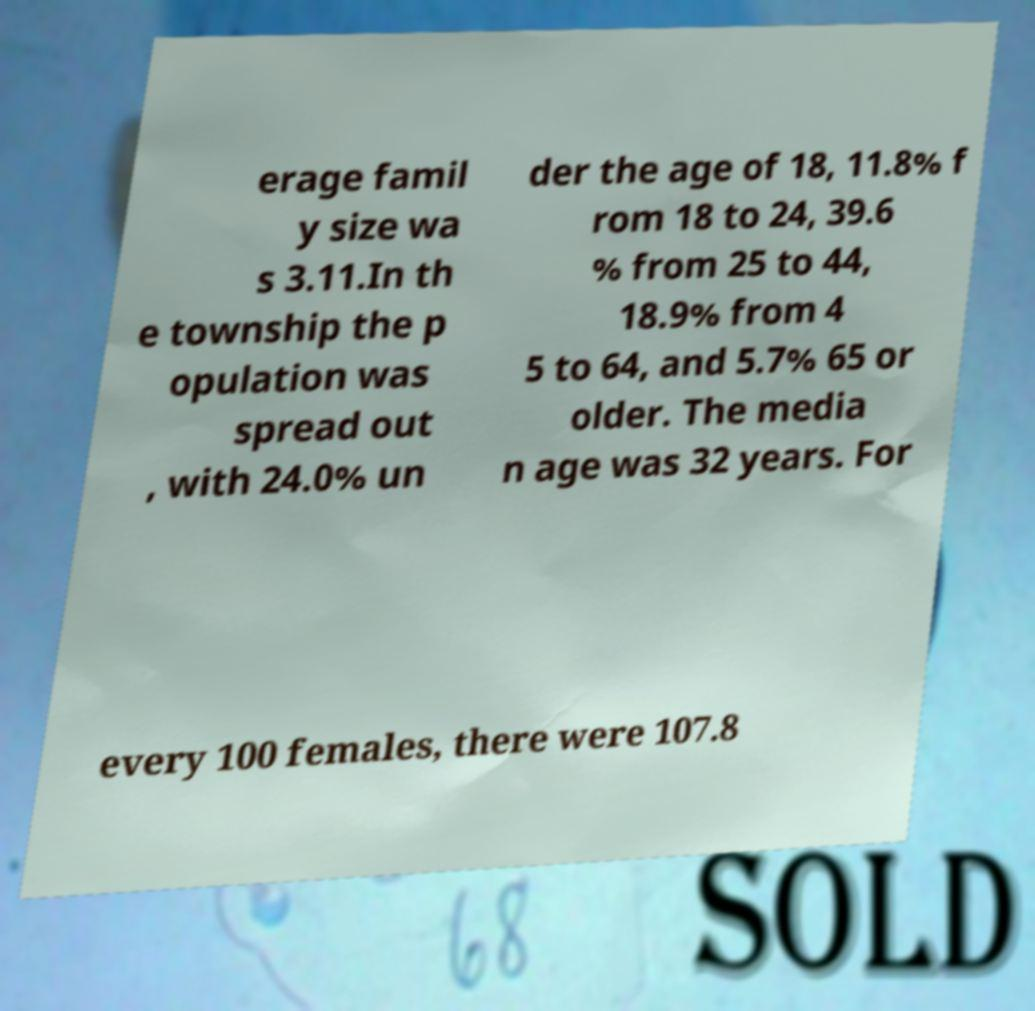Could you assist in decoding the text presented in this image and type it out clearly? erage famil y size wa s 3.11.In th e township the p opulation was spread out , with 24.0% un der the age of 18, 11.8% f rom 18 to 24, 39.6 % from 25 to 44, 18.9% from 4 5 to 64, and 5.7% 65 or older. The media n age was 32 years. For every 100 females, there were 107.8 